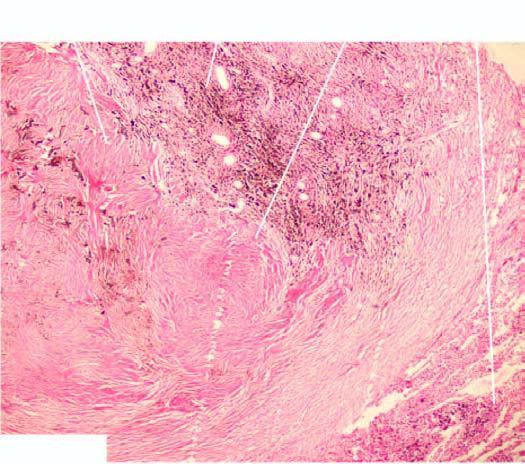re the chambers distended?
Answer the question using a single word or phrase. No 